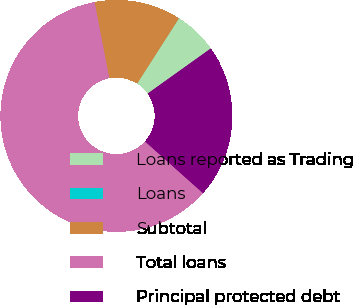Convert chart. <chart><loc_0><loc_0><loc_500><loc_500><pie_chart><fcel>Loans reported as Trading<fcel>Loans<fcel>Subtotal<fcel>Total loans<fcel>Principal protected debt<nl><fcel>6.05%<fcel>0.01%<fcel>12.09%<fcel>60.38%<fcel>21.47%<nl></chart> 